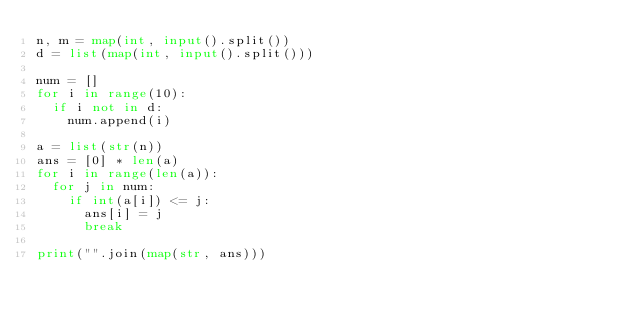<code> <loc_0><loc_0><loc_500><loc_500><_Python_>n, m = map(int, input().split())
d = list(map(int, input().split()))

num = []
for i in range(10):
  if i not in d:
    num.append(i)

a = list(str(n))
ans = [0] * len(a)
for i in range(len(a)):
  for j in num:
    if int(a[i]) <= j:
      ans[i] = j
      break

print("".join(map(str, ans)))
</code> 